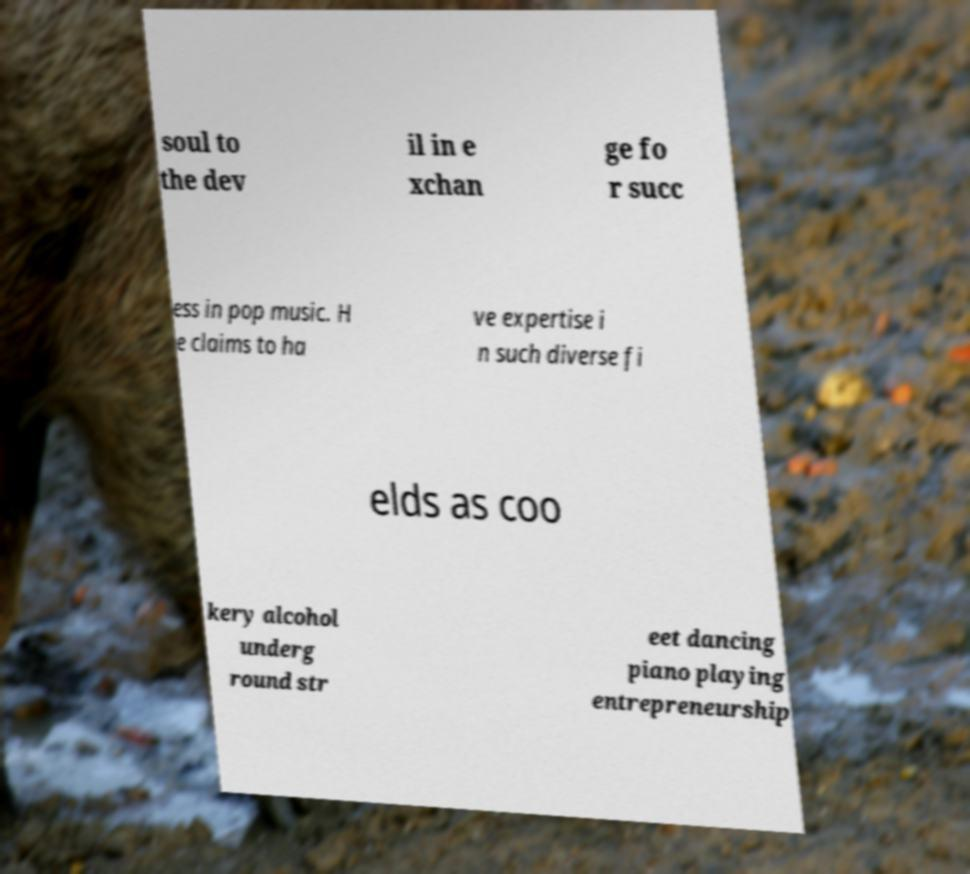Could you extract and type out the text from this image? soul to the dev il in e xchan ge fo r succ ess in pop music. H e claims to ha ve expertise i n such diverse fi elds as coo kery alcohol underg round str eet dancing piano playing entrepreneurship 